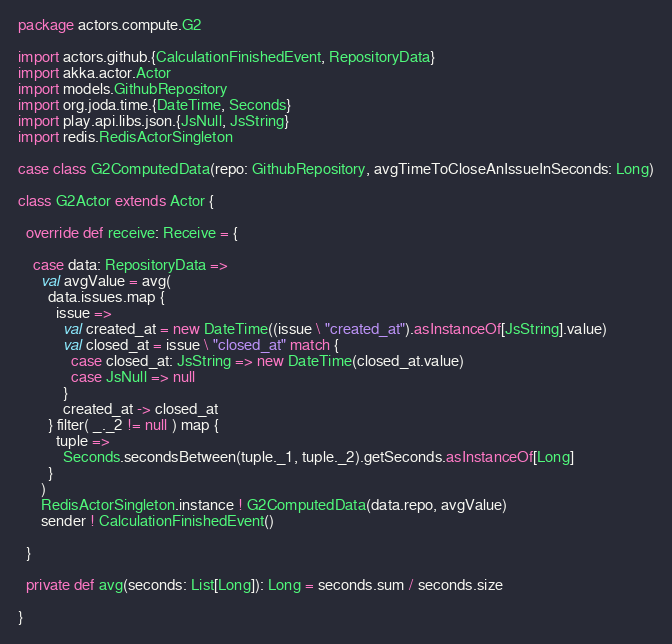Convert code to text. <code><loc_0><loc_0><loc_500><loc_500><_Scala_>package actors.compute.G2

import actors.github.{CalculationFinishedEvent, RepositoryData}
import akka.actor.Actor
import models.GithubRepository
import org.joda.time.{DateTime, Seconds}
import play.api.libs.json.{JsNull, JsString}
import redis.RedisActorSingleton

case class G2ComputedData(repo: GithubRepository, avgTimeToCloseAnIssueInSeconds: Long)

class G2Actor extends Actor {

  override def receive: Receive = {

    case data: RepositoryData =>
      val avgValue = avg(
        data.issues.map {
          issue =>
            val created_at = new DateTime((issue \ "created_at").asInstanceOf[JsString].value)
            val closed_at = issue \ "closed_at" match {
              case closed_at: JsString => new DateTime(closed_at.value)
              case JsNull => null
            }
            created_at -> closed_at
        } filter( _._2 != null ) map {
          tuple =>
            Seconds.secondsBetween(tuple._1, tuple._2).getSeconds.asInstanceOf[Long]
        }
      )
      RedisActorSingleton.instance ! G2ComputedData(data.repo, avgValue)
      sender ! CalculationFinishedEvent()

  }

  private def avg(seconds: List[Long]): Long = seconds.sum / seconds.size

}
</code> 